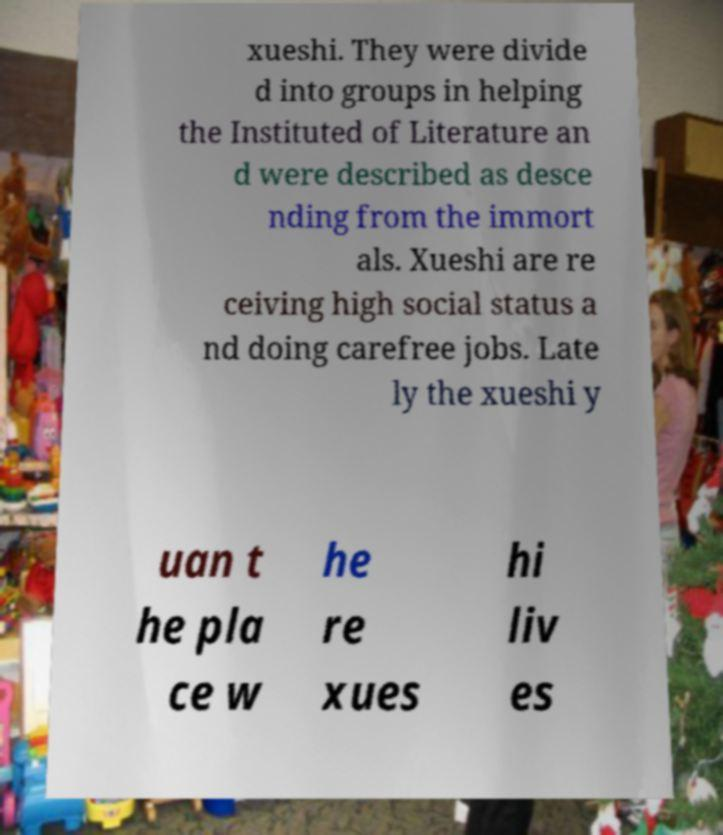I need the written content from this picture converted into text. Can you do that? xueshi. They were divide d into groups in helping the Instituted of Literature an d were described as desce nding from the immort als. Xueshi are re ceiving high social status a nd doing carefree jobs. Late ly the xueshi y uan t he pla ce w he re xues hi liv es 